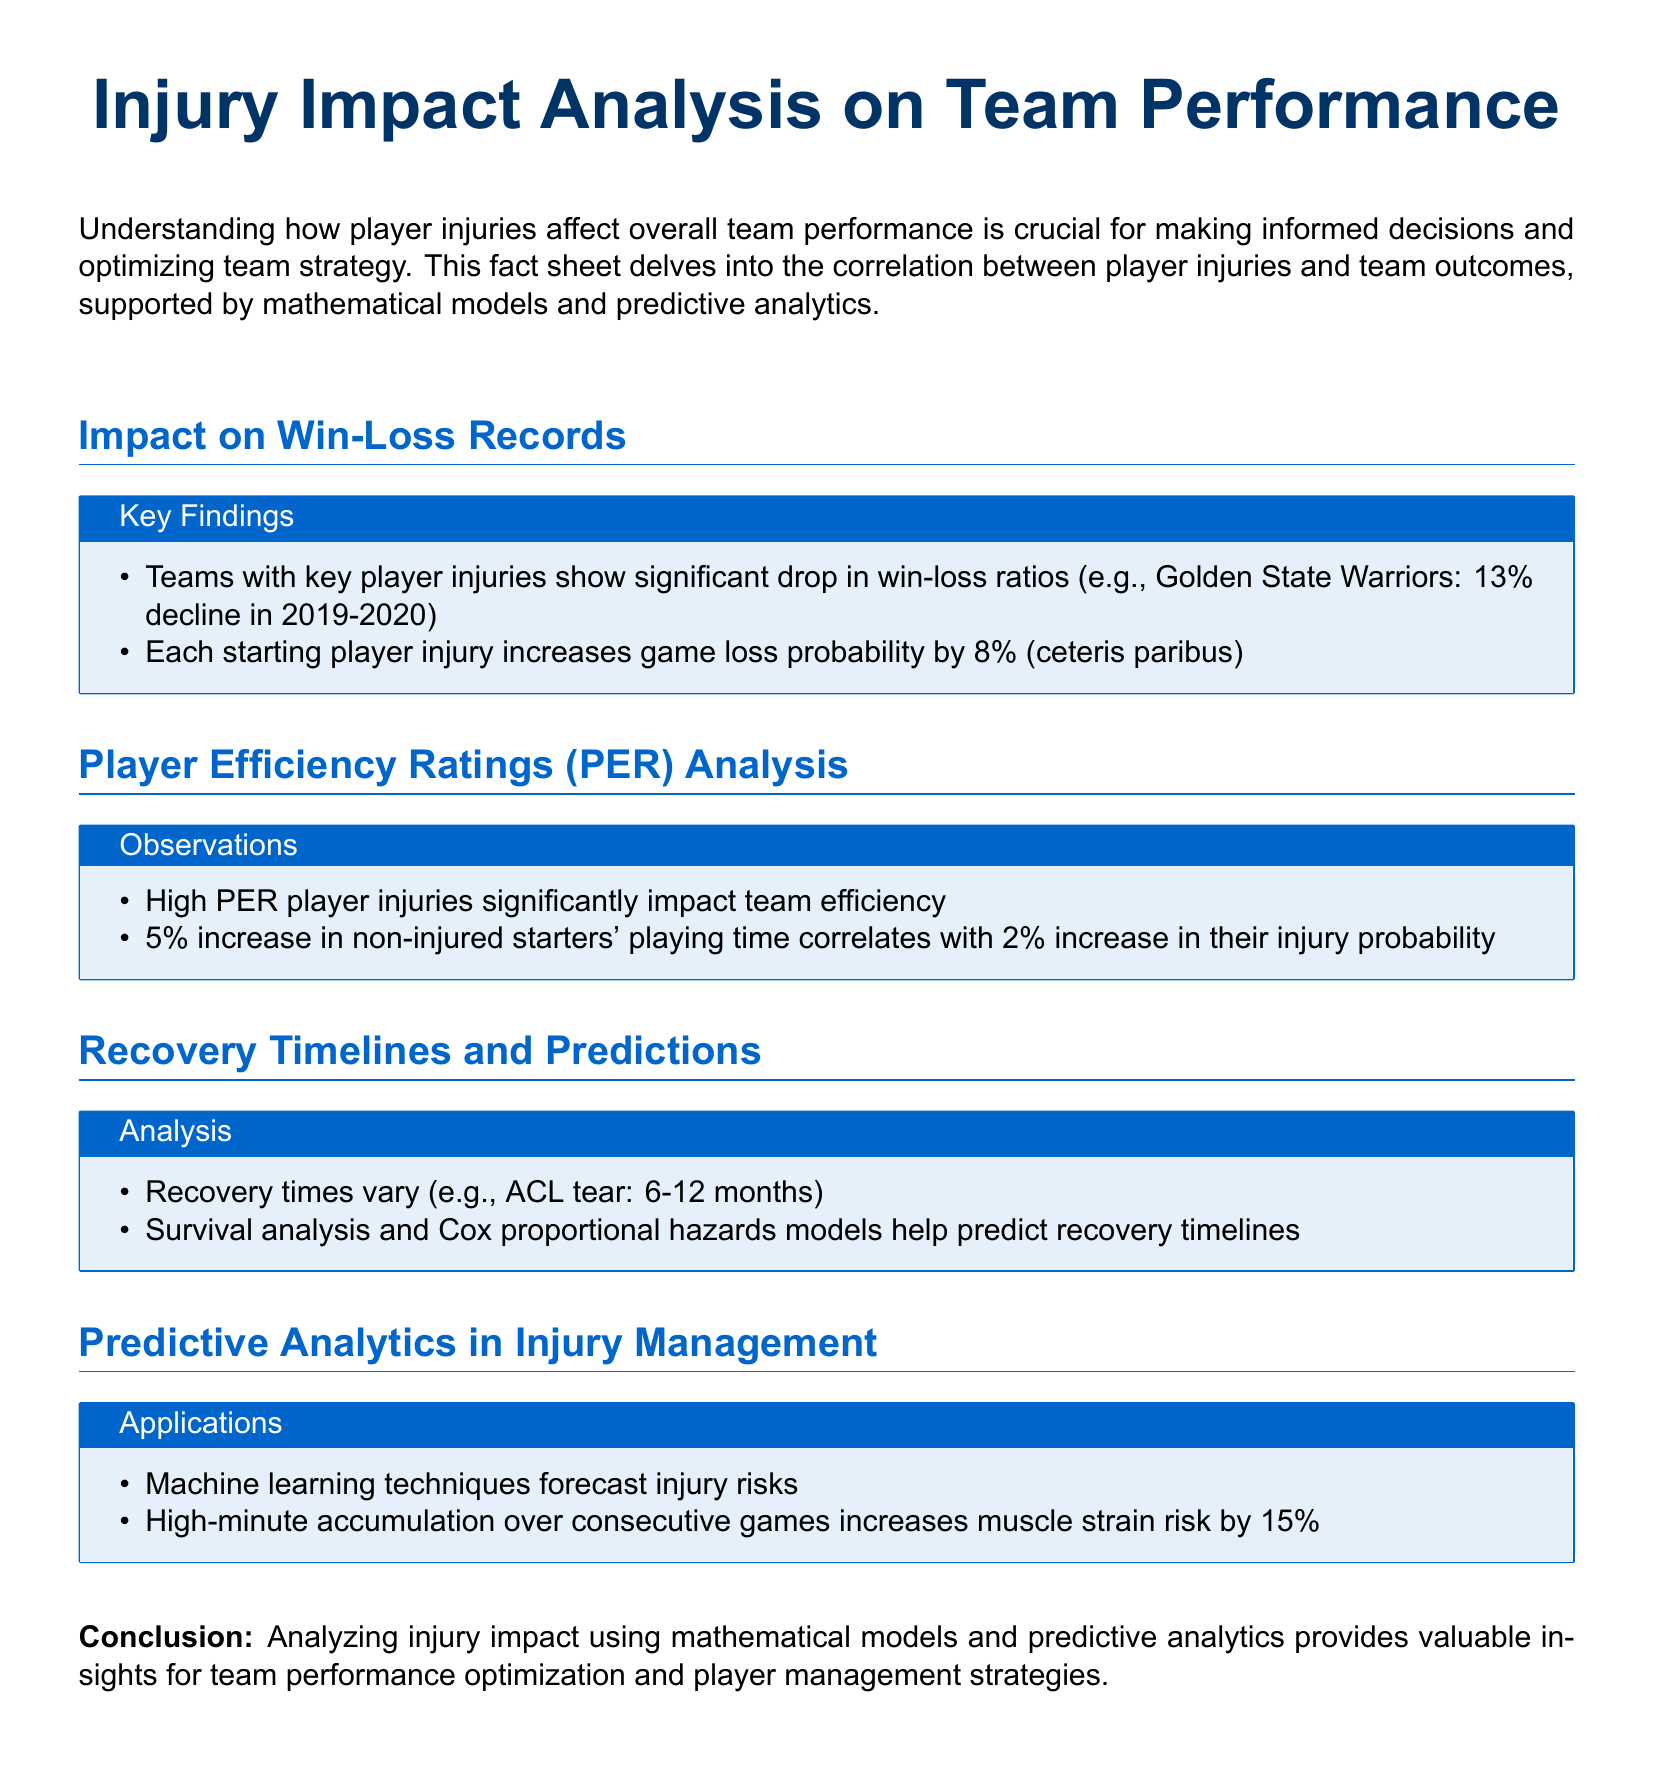What is the significant decline in win-loss ratios for the Golden State Warriors? The document states a 13% decline in win-loss ratios for the Golden State Warriors in 2019-2020.
Answer: 13% How much does each starting player injury increase game loss probability? The document mentions an 8% increase in game loss probability for each starting player injury.
Answer: 8% What do high PER player injuries affect? The document indicates that high PER player injuries significantly impact team efficiency.
Answer: Team efficiency What is the recovery time range for an ACL tear? The document provides a recovery time range of 6-12 months for an ACL tear.
Answer: 6-12 months What percentage does muscle strain risk increase due to high-minute accumulation over consecutive games? The document states the muscle strain risk increases by 15% due to high-minute accumulation.
Answer: 15% Which models help predict recovery timelines? The document mentions survival analysis and Cox proportional hazards models to predict recovery timelines.
Answer: Cox proportional hazards models What does a 5% increase in non-injured starters' playing time correlate with? The document notes a 2% increase in injury probability correlates with a 5% increase in non-injured starters' playing time.
Answer: 2% increase in injury probability What techniques forecast injury risks? The document states that machine learning techniques are used to forecast injury risks.
Answer: Machine learning techniques 